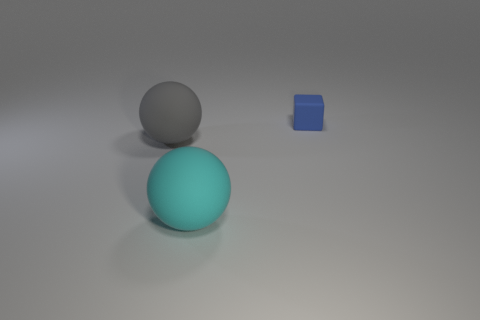Subtract all gray balls. How many balls are left? 1 Subtract 1 spheres. How many spheres are left? 1 Add 3 brown metallic blocks. How many objects exist? 6 Subtract all balls. How many objects are left? 1 Subtract all gray spheres. Subtract all big gray spheres. How many objects are left? 1 Add 3 gray objects. How many gray objects are left? 4 Add 2 blocks. How many blocks exist? 3 Subtract 0 brown balls. How many objects are left? 3 Subtract all red blocks. Subtract all blue balls. How many blocks are left? 1 